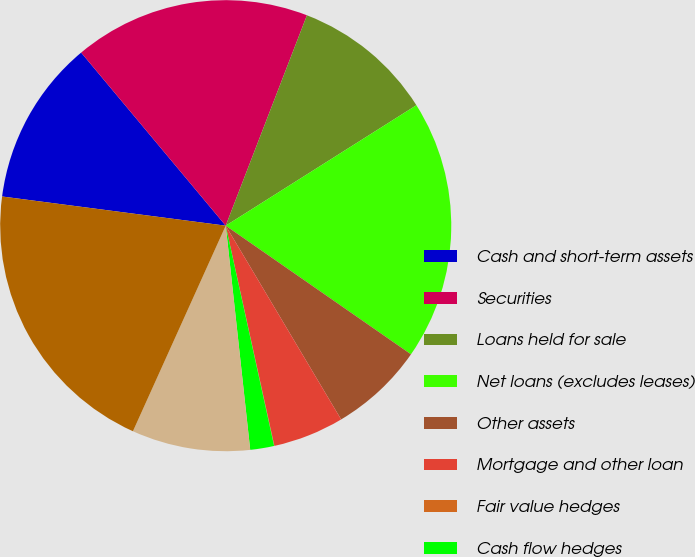Convert chart to OTSL. <chart><loc_0><loc_0><loc_500><loc_500><pie_chart><fcel>Cash and short-term assets<fcel>Securities<fcel>Loans held for sale<fcel>Net loans (excludes leases)<fcel>Other assets<fcel>Mortgage and other loan<fcel>Fair value hedges<fcel>Cash flow hedges<fcel>Free-standing derivatives<fcel>Demand savings and money<nl><fcel>11.86%<fcel>16.94%<fcel>10.17%<fcel>18.63%<fcel>6.79%<fcel>5.09%<fcel>0.02%<fcel>1.71%<fcel>8.48%<fcel>20.32%<nl></chart> 